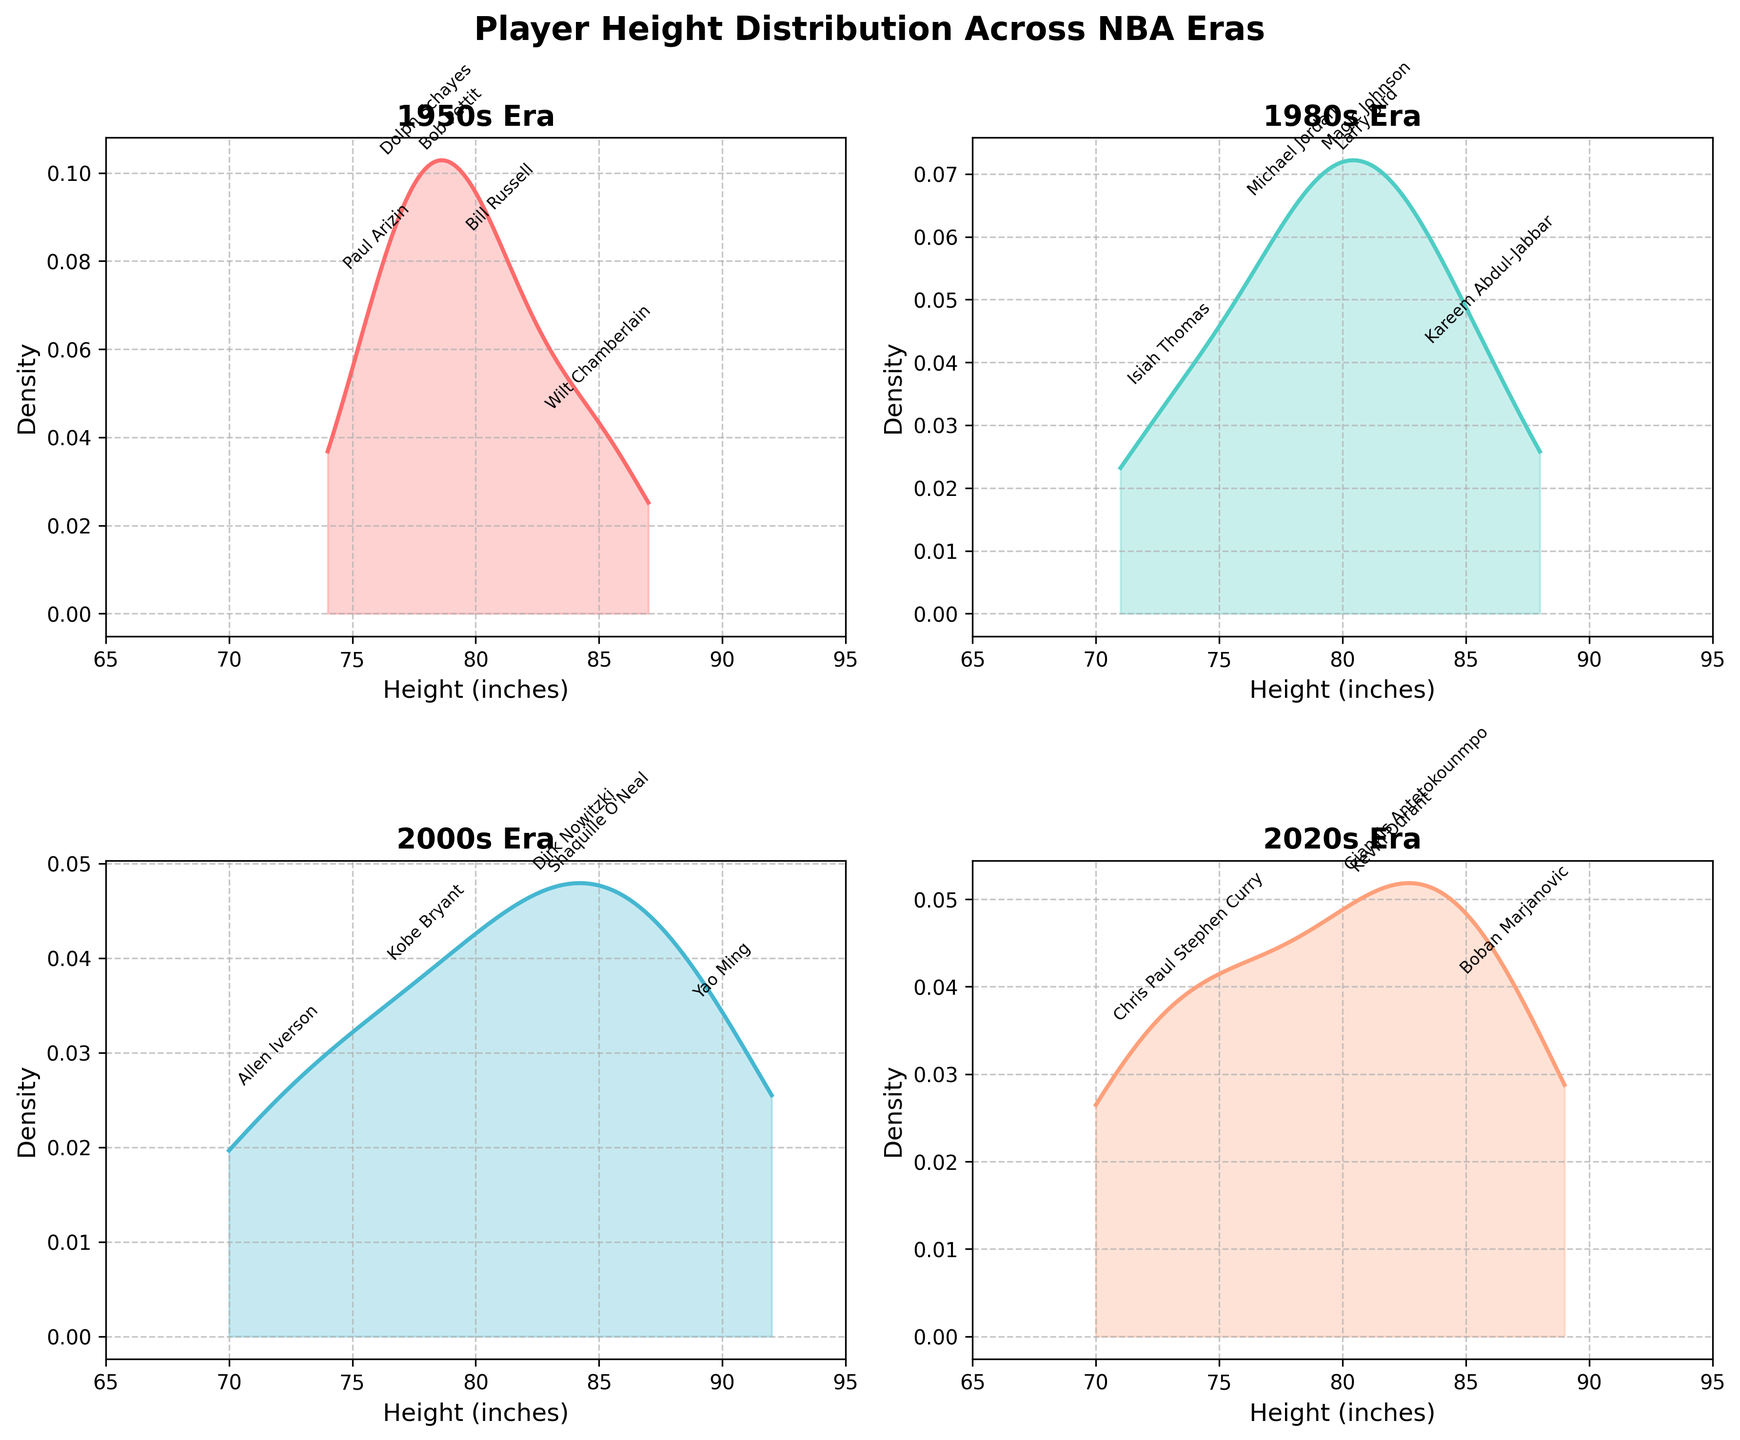What is the title of the figure? The title is typically found at the top of the figure and summarizes or describes what the figure is about.
Answer: Player Height Distribution Across NBA Eras How many eras are compared in the figure? By counting the number of subplots or analyzing the legend, you can see there are four eras compared.
Answer: Four Which era shows the tallest player, and who is it? By looking at the highest peak in the density plots and checking the annotated players, you find that the 2000s era shows Yao Ming as the tallest player.
Answer: 2000s, Yao Ming Which era has the shortest player, and who is it? By looking at the smallest value on the x-axis and the annotated players, you find that the 2000s and 2020s era show Allen Iverson and Chris Paul as the shortest players.
Answer: 2000s, Allen Iverson and 2020s, Chris Paul (tie) How does the height distribution in the 1980s compare to the 2020s? By comparing the shapes and peaks of the density plots for the 1980s and 2020s subplots, you observe that the 1980s has a more concentrated distribution around 78-81 inches, while the 2020s has a flatter, more spread-out distribution, ranging from 72 to 87 inches.
Answer: 1980s: more concentrated, 2020s: more spread-out Which era has the widest range of player heights? By comparing the spread of x-axis values for density plots across all eras, you see that the 2020s era has height ranging from 72 to 87 inches which is the widest.
Answer: 2020s Are there more tall players (above 80 inches) in the 2000s or the 1950s based on the density plots? Observing the areas under the curves above 80 inches for both 2000s and 1950s, you see the 2000s has a larger area indicating more tall players.
Answer: 2000s Which era density plot shows the highest peak and what approximate height does this correspond to? By identifying the tallest peak among the density plots, you find the 1980s era has the highest peak, and it corresponds to around 81 inches.
Answer: 1980s, ~81 inches How are the heights distributed in the 1950s era? By analyzing the density plot for the 1950s, you observe a distribution with peaks around 76-85 inches, indicating a central tendency within this range.
Answer: Peaks around 76-85 inches Comparing the 1950s and 2000s, which era includes players with heights closest to the average human height (around 70 inches)? By observing the density plots, the 1950s include players like Paul Arizin at 76 inches, while no players in the 2000s are close to 70 inches, with the shortest being 72 inches.
Answer: 1950s 